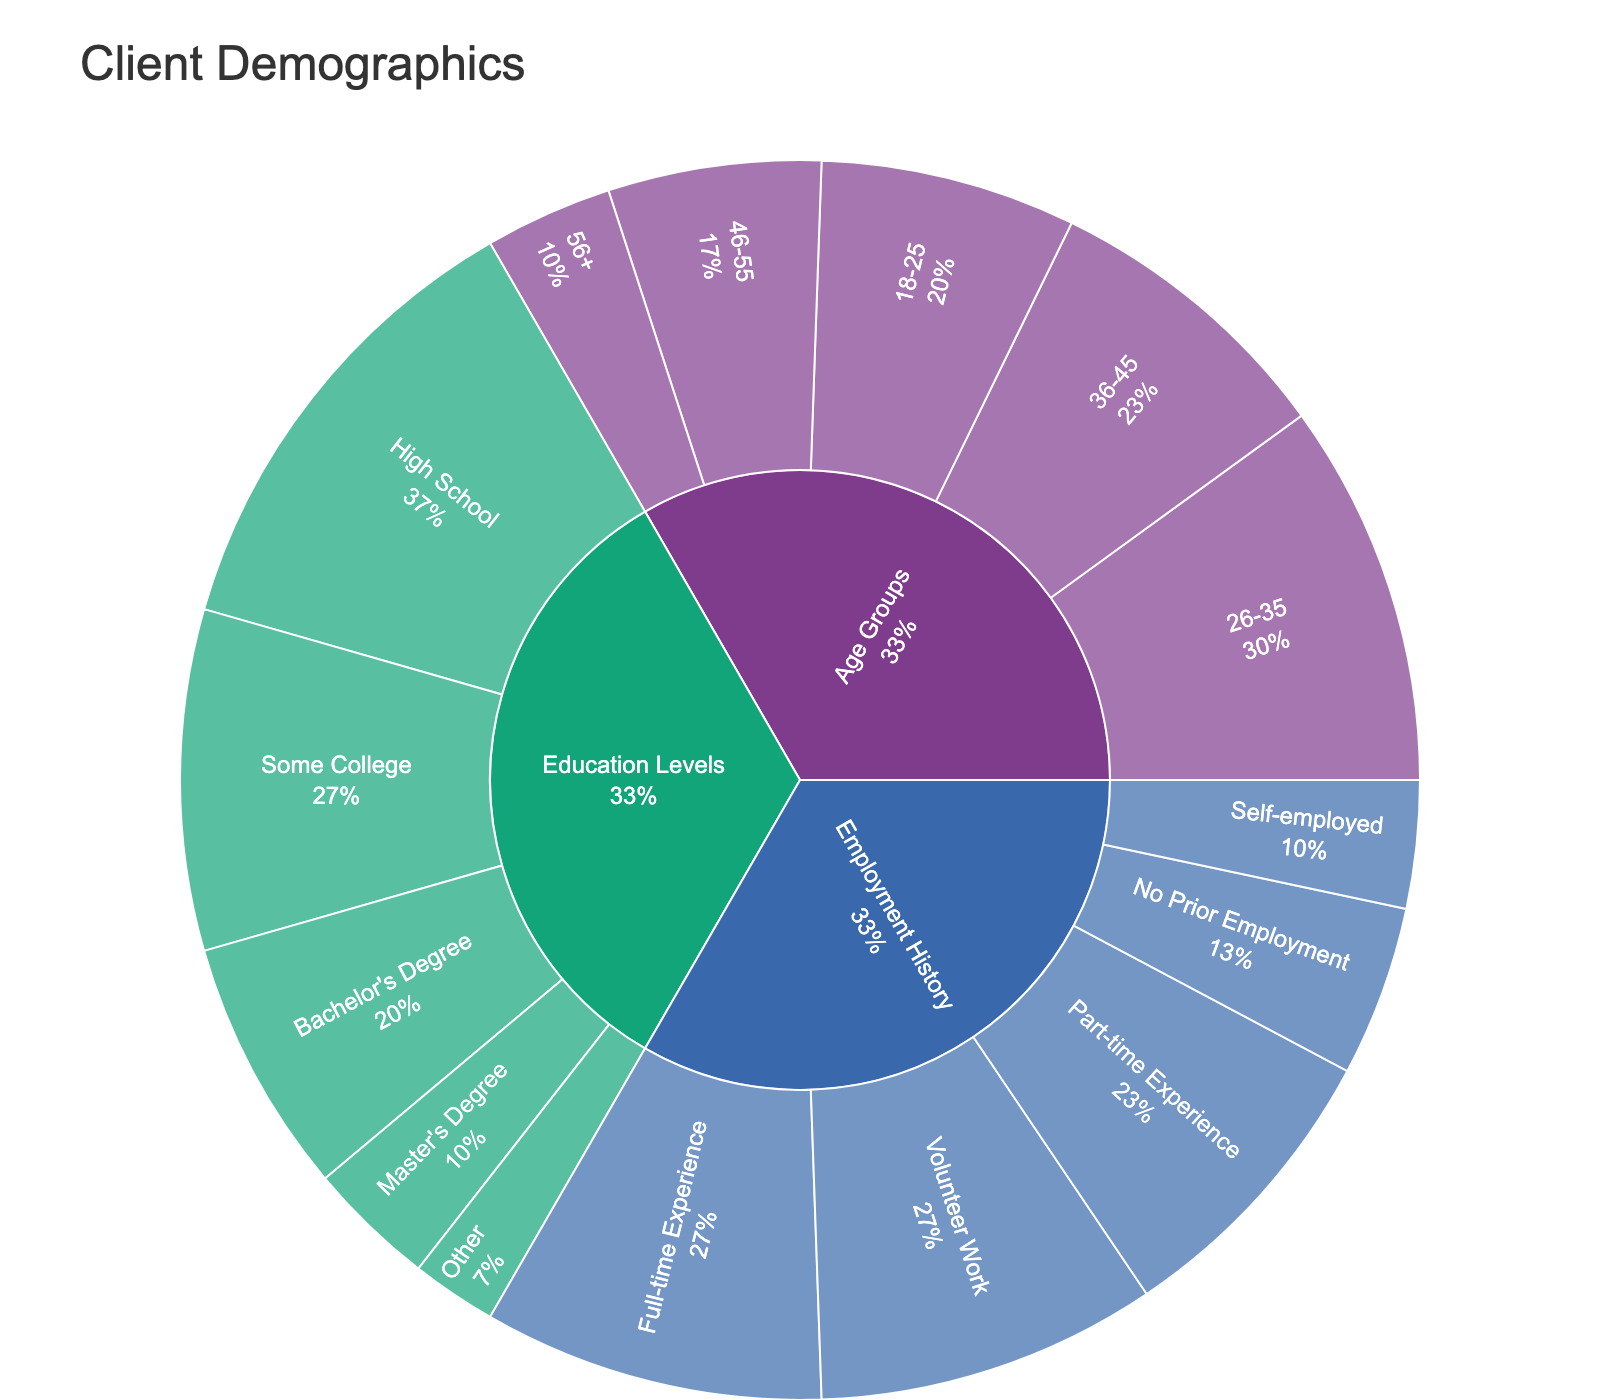What is the title of the figure? The title is usually at the top of the figure. In this case, it indicates the overall topic of the visualization.
Answer: Client Demographics How many age groups are represented in the figure? Look at the segments under the "Age Groups" category. Count the different subcategories within it.
Answer: 5 Which age group has the largest population? Identify the segment with the largest value under the "Age Groups" category.
Answer: 26-35 Which education level has the smallest population? Identify the segment with the smallest value under the "Education Levels" category.
Answer: Other What is the combined population of clients with a Bachelor's Degree and a Master's Degree? Sum the values of the segments labeled "Bachelor's Degree" and "Master's Degree" under the "Education Levels" category. 30 + 15 = 45
Answer: 45 How does the population of the 18-25 age group compare to those with No Prior Employment? Compare the values of the segments labeled "18-25" under "Age Groups" and "No Prior Employment" under "Employment History". 30 vs 20.
Answer: 18-25 is larger Which employment history category has the most clients? Identify the segment with the largest value under the "Employment History" category.
Answer: Full-time Experience and Volunteer Work What percentage of clients have some college education? Look at the percentage information provided for the "Some College" segment under "Education Levels".
Answer: Calculation depends on the total but usually, it's indicated in the plot. Inferred from examples, we can estimate around 28% How does the total population with part-time experience compare to those with full-time experience? Compare the values of the segments labeled "Part-time Experience" and "Full-time Experience" under "Employment History" category. 35 vs 40
Answer: Full-time Experience is larger 